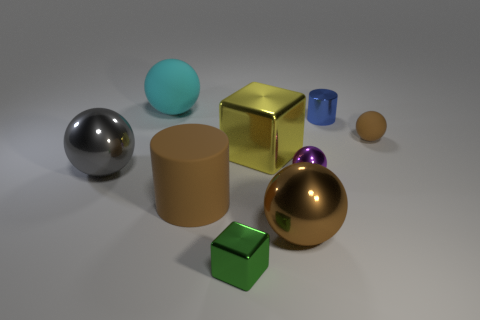There is a shiny object to the left of the cyan matte thing; what size is it?
Your answer should be very brief. Large. The yellow object has what size?
Provide a short and direct response. Large. How many cylinders are gray metal objects or tiny brown objects?
Give a very brief answer. 0. What is the size of the blue cylinder that is the same material as the big yellow thing?
Your answer should be very brief. Small. How many matte things are the same color as the tiny metal cube?
Your answer should be very brief. 0. There is a tiny rubber ball; are there any cyan balls in front of it?
Your answer should be very brief. No. Does the big yellow metal thing have the same shape as the brown rubber object that is on the right side of the small blue cylinder?
Make the answer very short. No. How many objects are either tiny metallic things that are behind the purple shiny object or rubber objects?
Offer a very short reply. 4. Is there any other thing that is the same material as the green block?
Your response must be concise. Yes. How many large rubber things are both behind the tiny purple object and in front of the purple shiny ball?
Offer a very short reply. 0. 